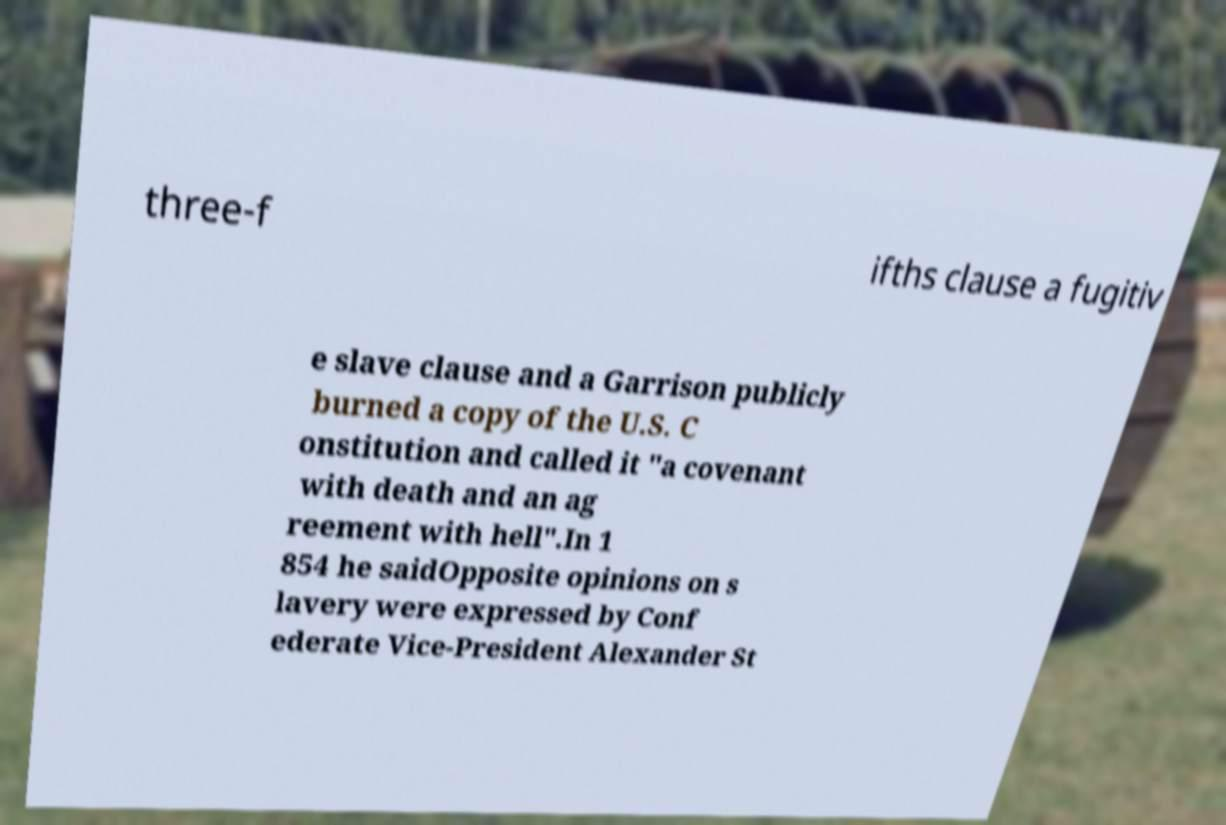Please identify and transcribe the text found in this image. three-f ifths clause a fugitiv e slave clause and a Garrison publicly burned a copy of the U.S. C onstitution and called it "a covenant with death and an ag reement with hell".In 1 854 he saidOpposite opinions on s lavery were expressed by Conf ederate Vice-President Alexander St 